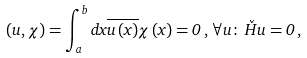<formula> <loc_0><loc_0><loc_500><loc_500>\left ( u , \chi \right ) = \int _ { a } ^ { b } d x \overline { u \left ( x \right ) } \chi \left ( x \right ) = 0 \, , \, \forall u \colon \, \check { H } u = 0 \, ,</formula> 